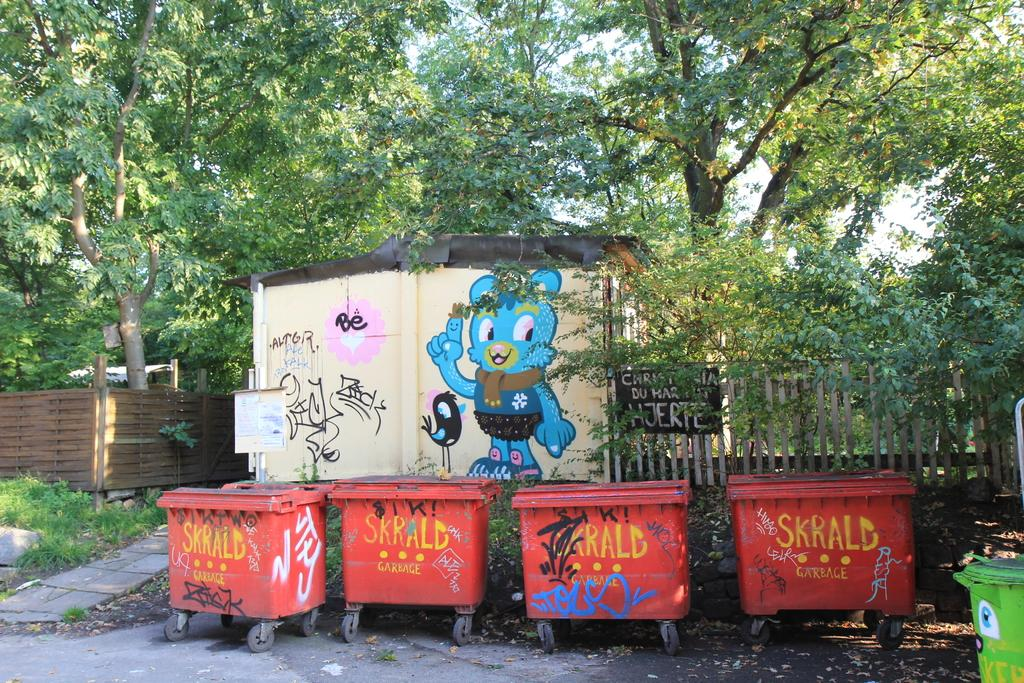<image>
Write a terse but informative summary of the picture. A group of Skrald trash bins in front of a cartoon bird painted on the wall. 